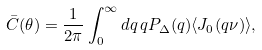Convert formula to latex. <formula><loc_0><loc_0><loc_500><loc_500>\bar { C } ( \theta ) = \frac { 1 } { 2 \pi } \int _ { 0 } ^ { \infty } d q \, q P _ { \Delta } ( q ) \langle J _ { 0 } ( q \nu ) \rangle ,</formula> 